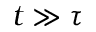Convert formula to latex. <formula><loc_0><loc_0><loc_500><loc_500>t \gg \tau</formula> 